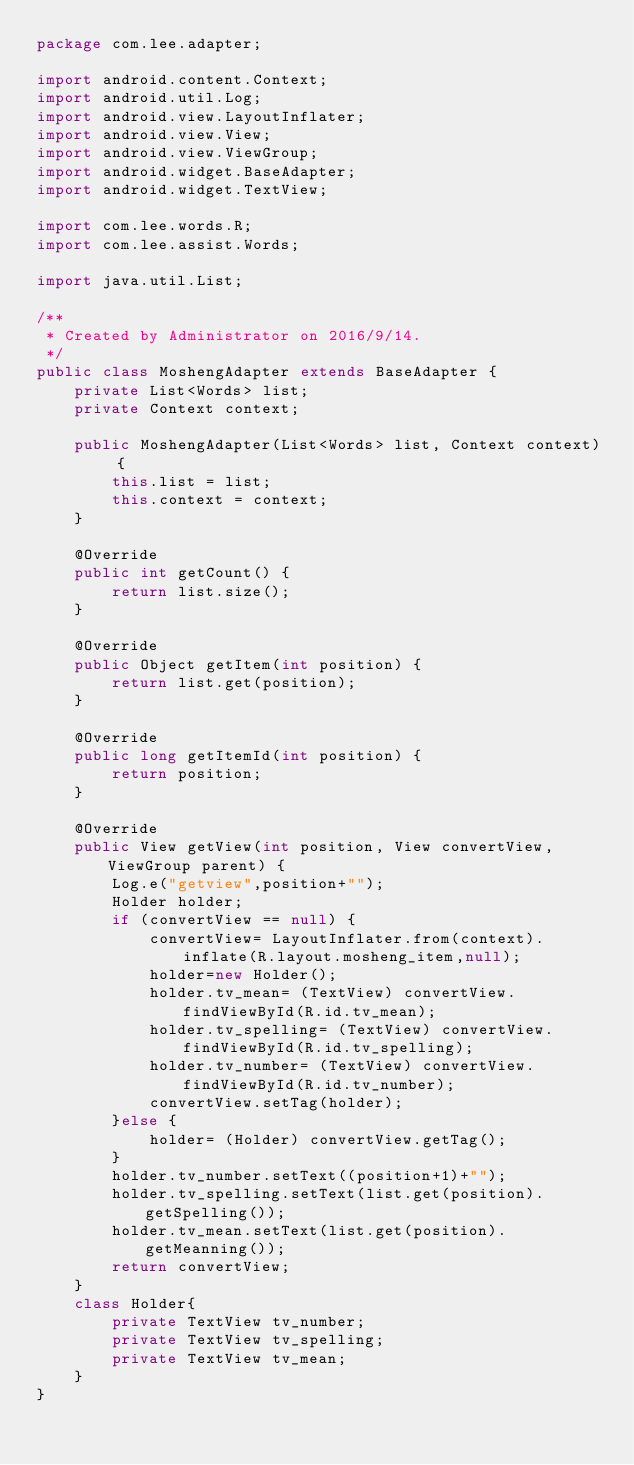Convert code to text. <code><loc_0><loc_0><loc_500><loc_500><_Java_>package com.lee.adapter;

import android.content.Context;
import android.util.Log;
import android.view.LayoutInflater;
import android.view.View;
import android.view.ViewGroup;
import android.widget.BaseAdapter;
import android.widget.TextView;

import com.lee.words.R;
import com.lee.assist.Words;

import java.util.List;

/**
 * Created by Administrator on 2016/9/14.
 */
public class MoshengAdapter extends BaseAdapter {
    private List<Words> list;
    private Context context;

    public MoshengAdapter(List<Words> list, Context context) {
        this.list = list;
        this.context = context;
    }

    @Override
    public int getCount() {
        return list.size();
    }

    @Override
    public Object getItem(int position) {
        return list.get(position);
    }

    @Override
    public long getItemId(int position) {
        return position;
    }

    @Override
    public View getView(int position, View convertView, ViewGroup parent) {
        Log.e("getview",position+"");
        Holder holder;
        if (convertView == null) {
            convertView= LayoutInflater.from(context).inflate(R.layout.mosheng_item,null);
            holder=new Holder();
            holder.tv_mean= (TextView) convertView.findViewById(R.id.tv_mean);
            holder.tv_spelling= (TextView) convertView.findViewById(R.id.tv_spelling);
            holder.tv_number= (TextView) convertView.findViewById(R.id.tv_number);
            convertView.setTag(holder);
        }else {
            holder= (Holder) convertView.getTag();
        }
        holder.tv_number.setText((position+1)+"");
        holder.tv_spelling.setText(list.get(position).getSpelling());
        holder.tv_mean.setText(list.get(position).getMeanning());
        return convertView;
    }
    class Holder{
        private TextView tv_number;
        private TextView tv_spelling;
        private TextView tv_mean;
    }
}
</code> 